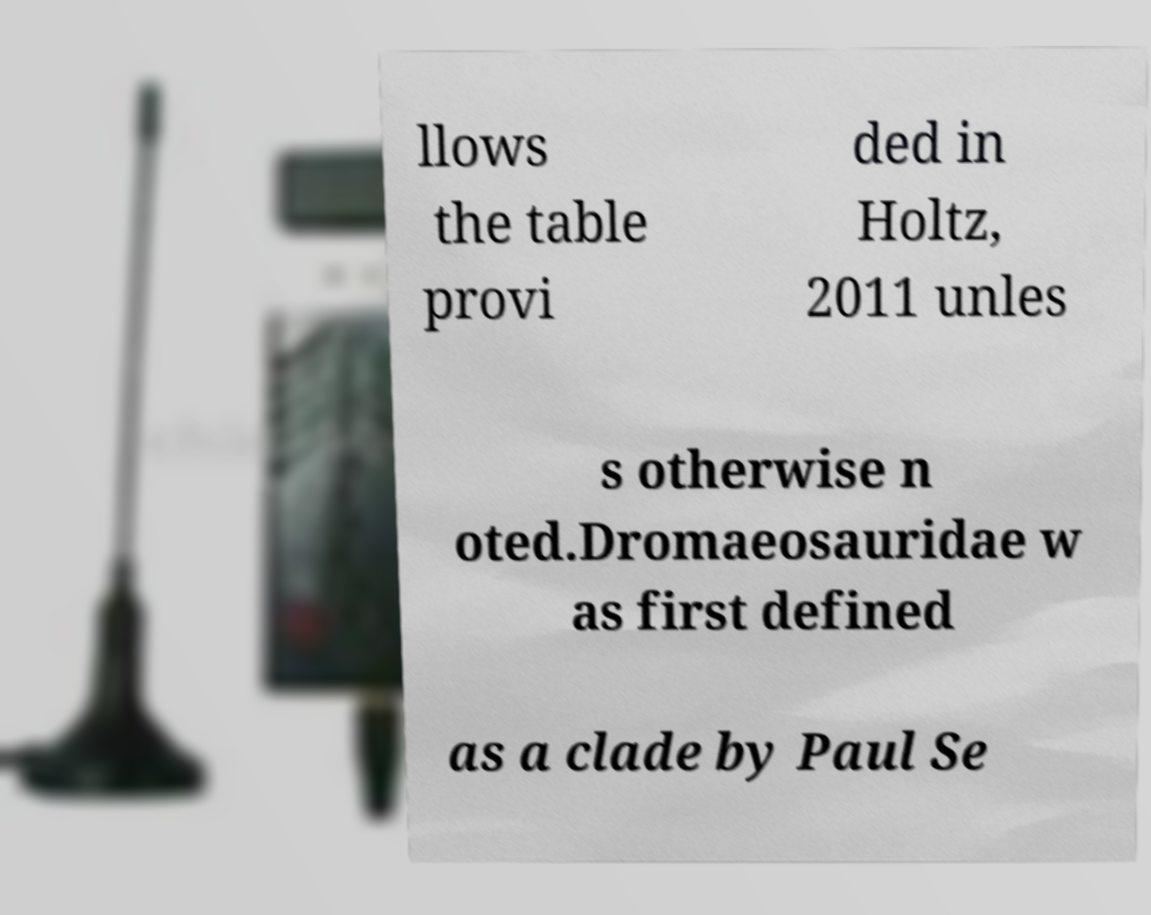For documentation purposes, I need the text within this image transcribed. Could you provide that? llows the table provi ded in Holtz, 2011 unles s otherwise n oted.Dromaeosauridae w as first defined as a clade by Paul Se 